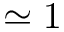<formula> <loc_0><loc_0><loc_500><loc_500>\simeq 1</formula> 